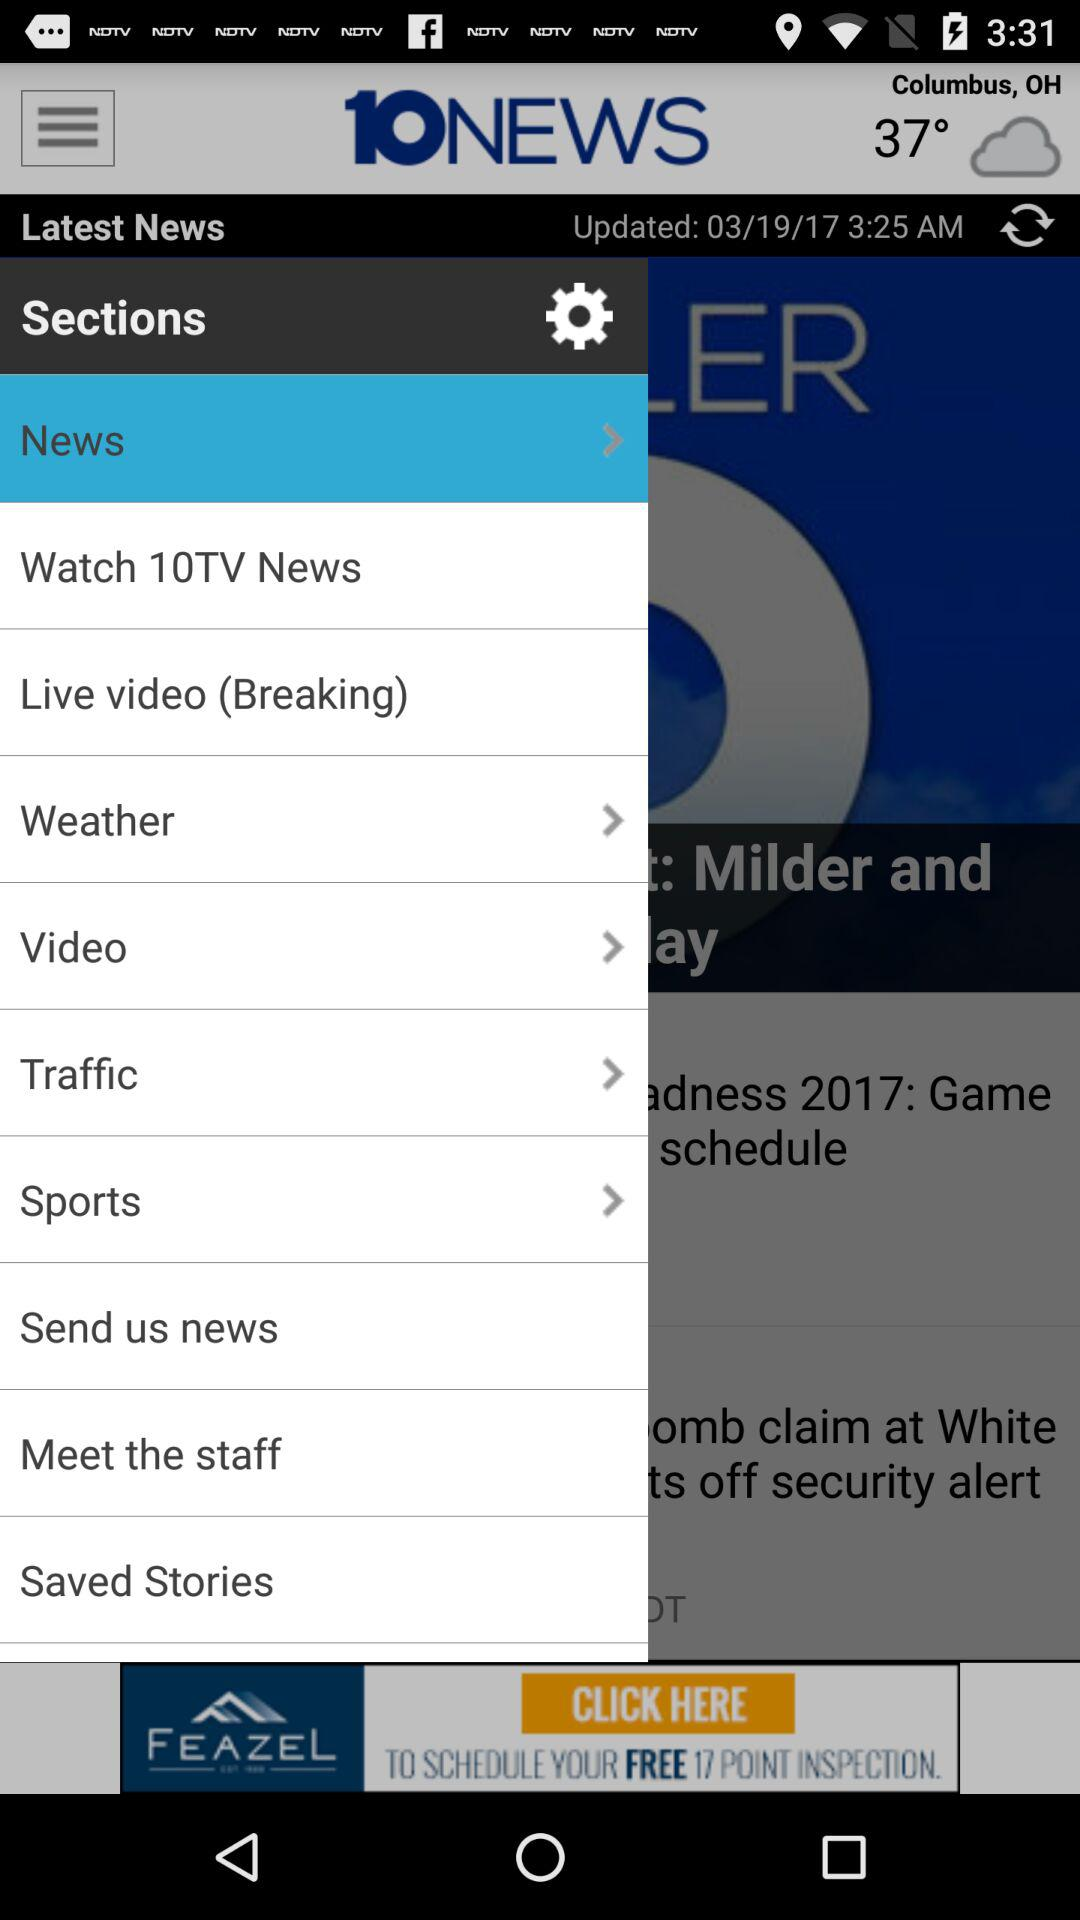When was the "Latest News" updated? The "Latest News" was updated on March 19, 2017 at 3:25 a.m. 